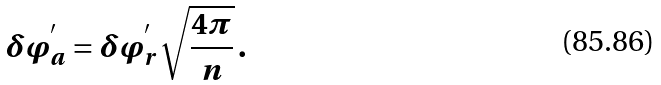Convert formula to latex. <formula><loc_0><loc_0><loc_500><loc_500>\delta \varphi _ { a } ^ { ^ { \prime } } = \delta \varphi _ { r } ^ { ^ { \prime } } \sqrt { \frac { 4 \pi } n } \, .</formula> 